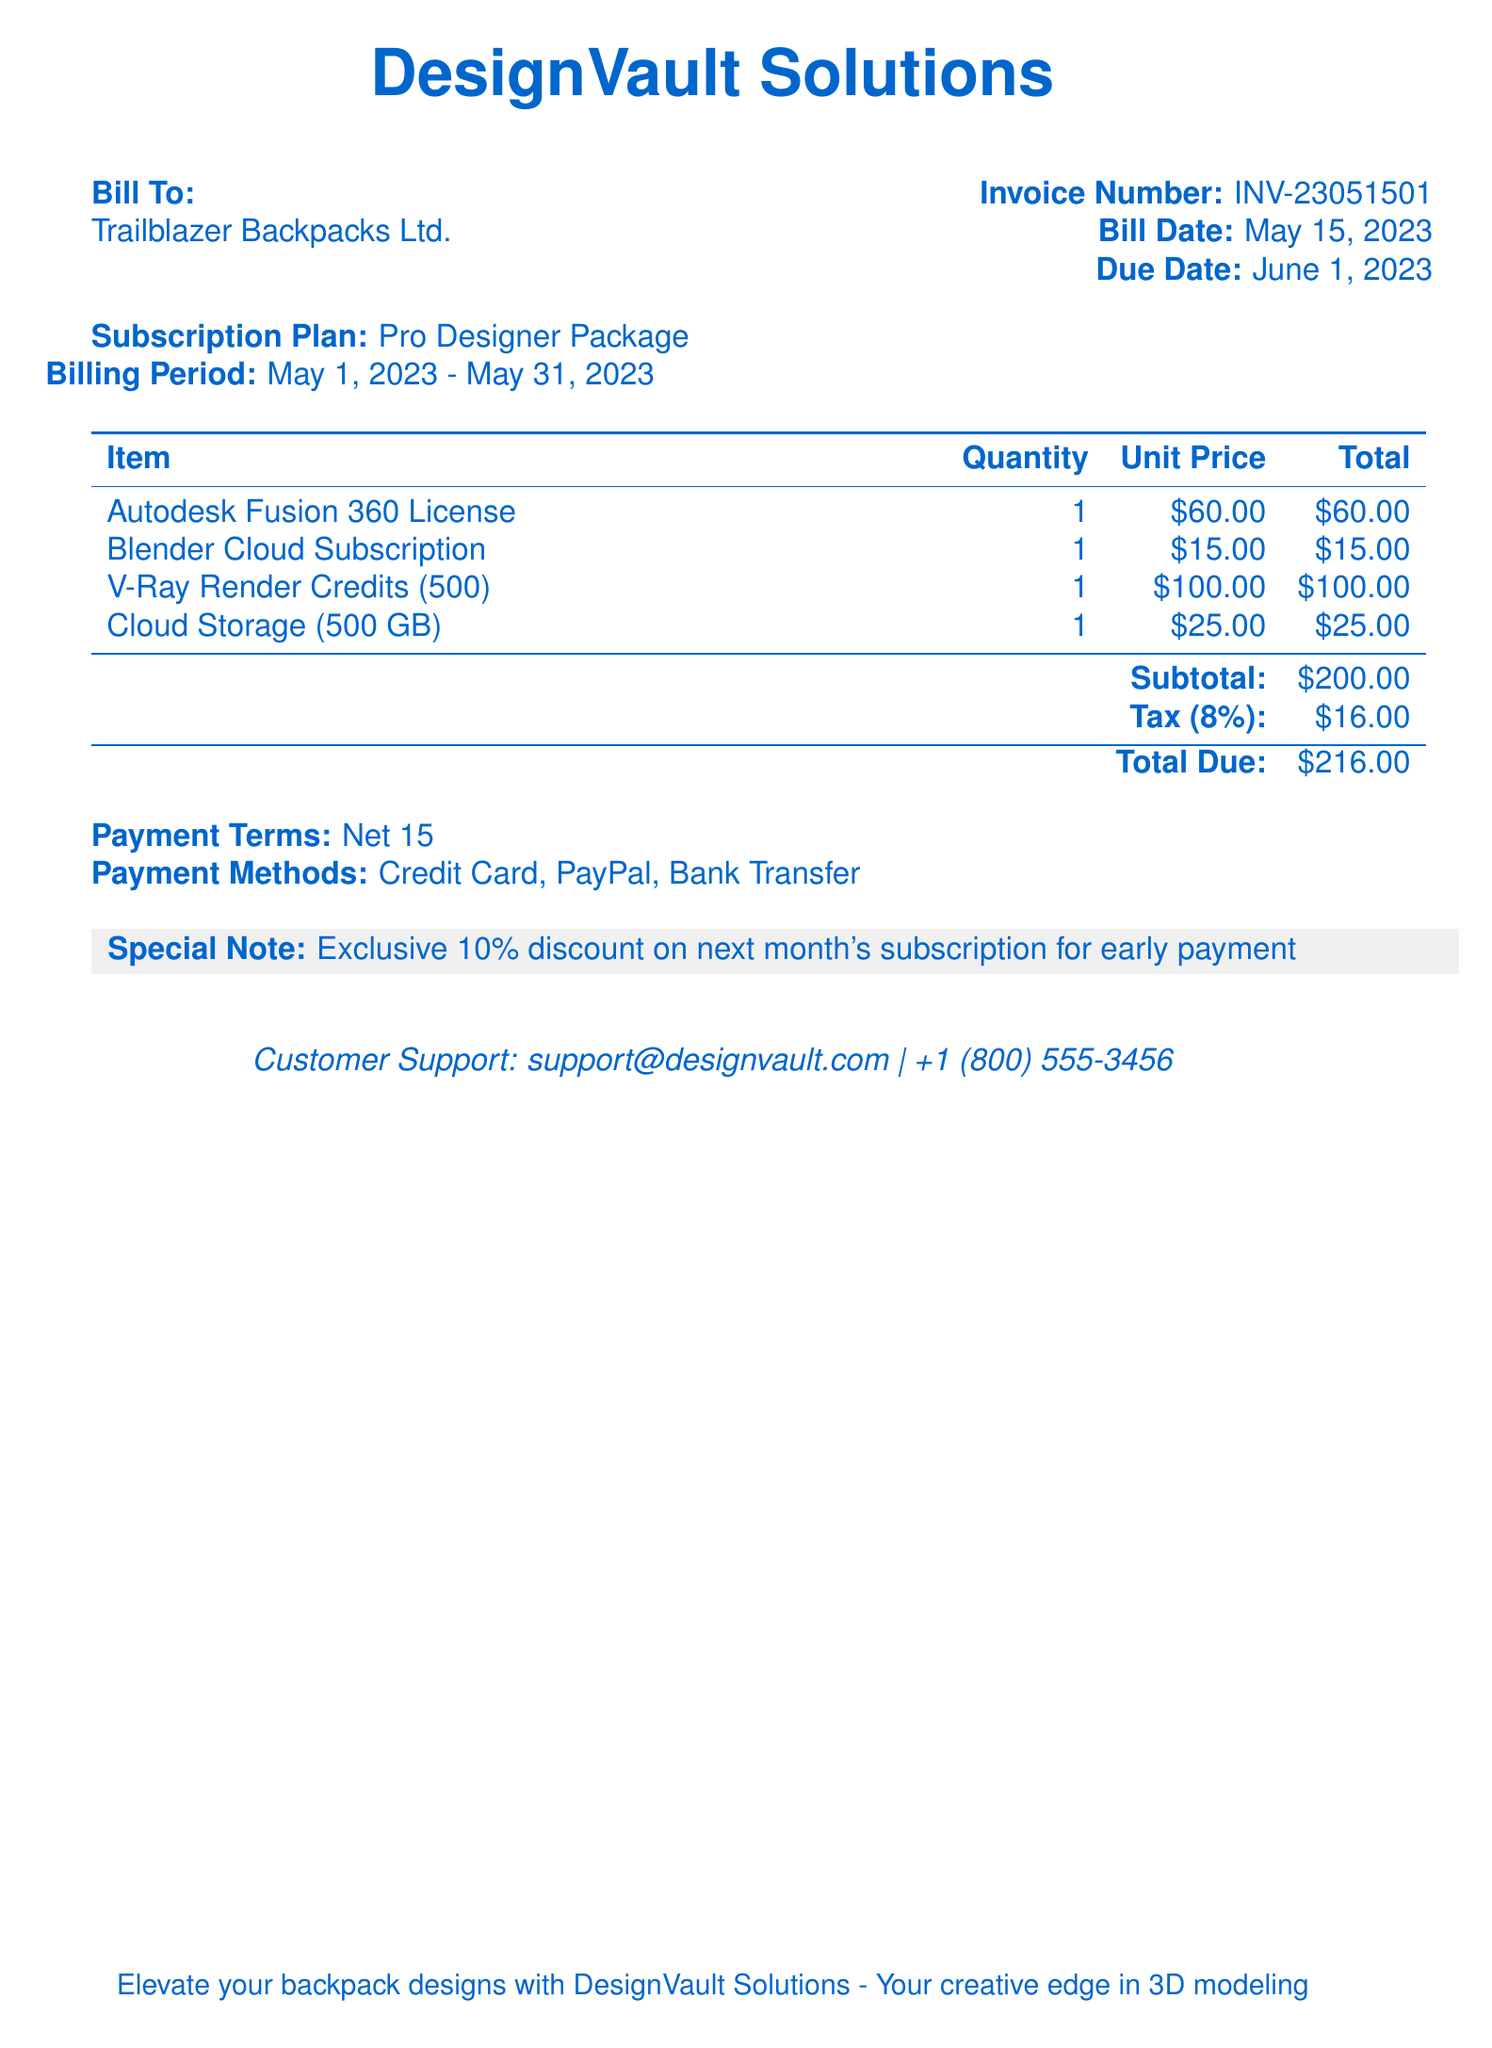What is the invoice number? The invoice number is listed in the document as INV-23051501.
Answer: INV-23051501 What is the bill date? The bill date indicates when the invoice was generated, given as May 15, 2023.
Answer: May 15, 2023 What is the total due amount? The total due amount is the final charge that must be paid, shown as $216.00.
Answer: $216.00 What subscription plan is mentioned? The subscription plan highlights the type of services provided, identified as Pro Designer Package.
Answer: Pro Designer Package How many render credits are included in the bill? The bill outlines the quantity of render credits, which is specified as 500.
Answer: 500 What is the tax percentage applied? The tax percentage indicates the rate at which tax is applied, indicated as 8%.
Answer: 8% What is the payment term stated in the document? The payment term specifies how long the customer has to pay, mentioned as Net 15.
Answer: Net 15 What discount is offered for early payment? The document provides details of a discount for early payment, which is 10%.
Answer: 10% 